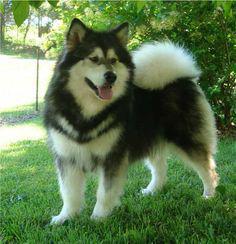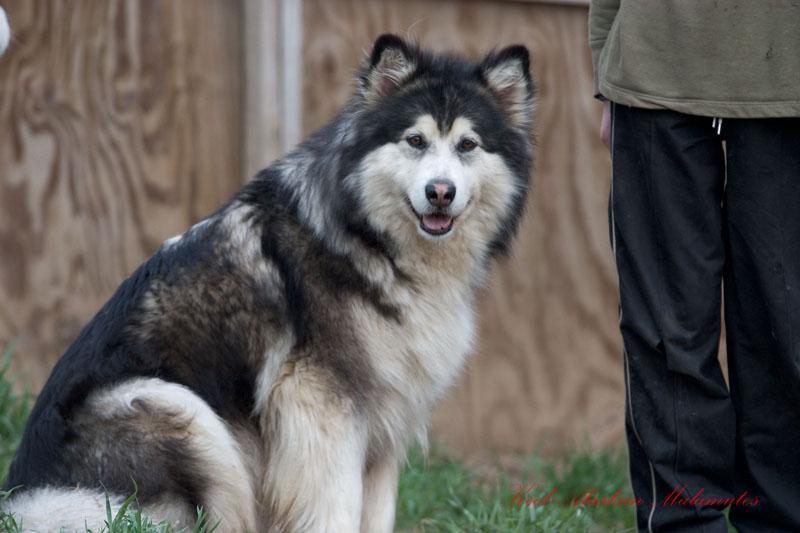The first image is the image on the left, the second image is the image on the right. For the images displayed, is the sentence "The left image features one standing open-mouthed dog, and the right image features one standing close-mouthed dog." factually correct? Answer yes or no. No. The first image is the image on the left, the second image is the image on the right. For the images shown, is this caption "In the image to the right, a human stands near the dogs." true? Answer yes or no. Yes. 